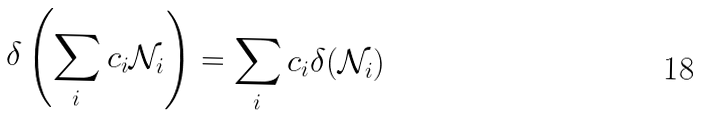<formula> <loc_0><loc_0><loc_500><loc_500>\delta \left ( \sum _ { i } c _ { i } \mathcal { N } _ { i } \right ) = \sum _ { i } c _ { i } \delta ( \mathcal { N } _ { i } )</formula> 